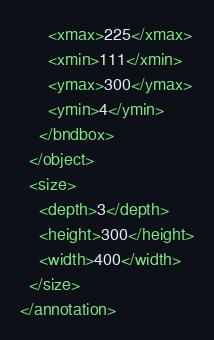<code> <loc_0><loc_0><loc_500><loc_500><_XML_>      <xmax>225</xmax>
      <xmin>111</xmin>
      <ymax>300</ymax>
      <ymin>4</ymin>
    </bndbox>
  </object>
  <size>
    <depth>3</depth>
    <height>300</height>
    <width>400</width>
  </size>
</annotation>
</code> 